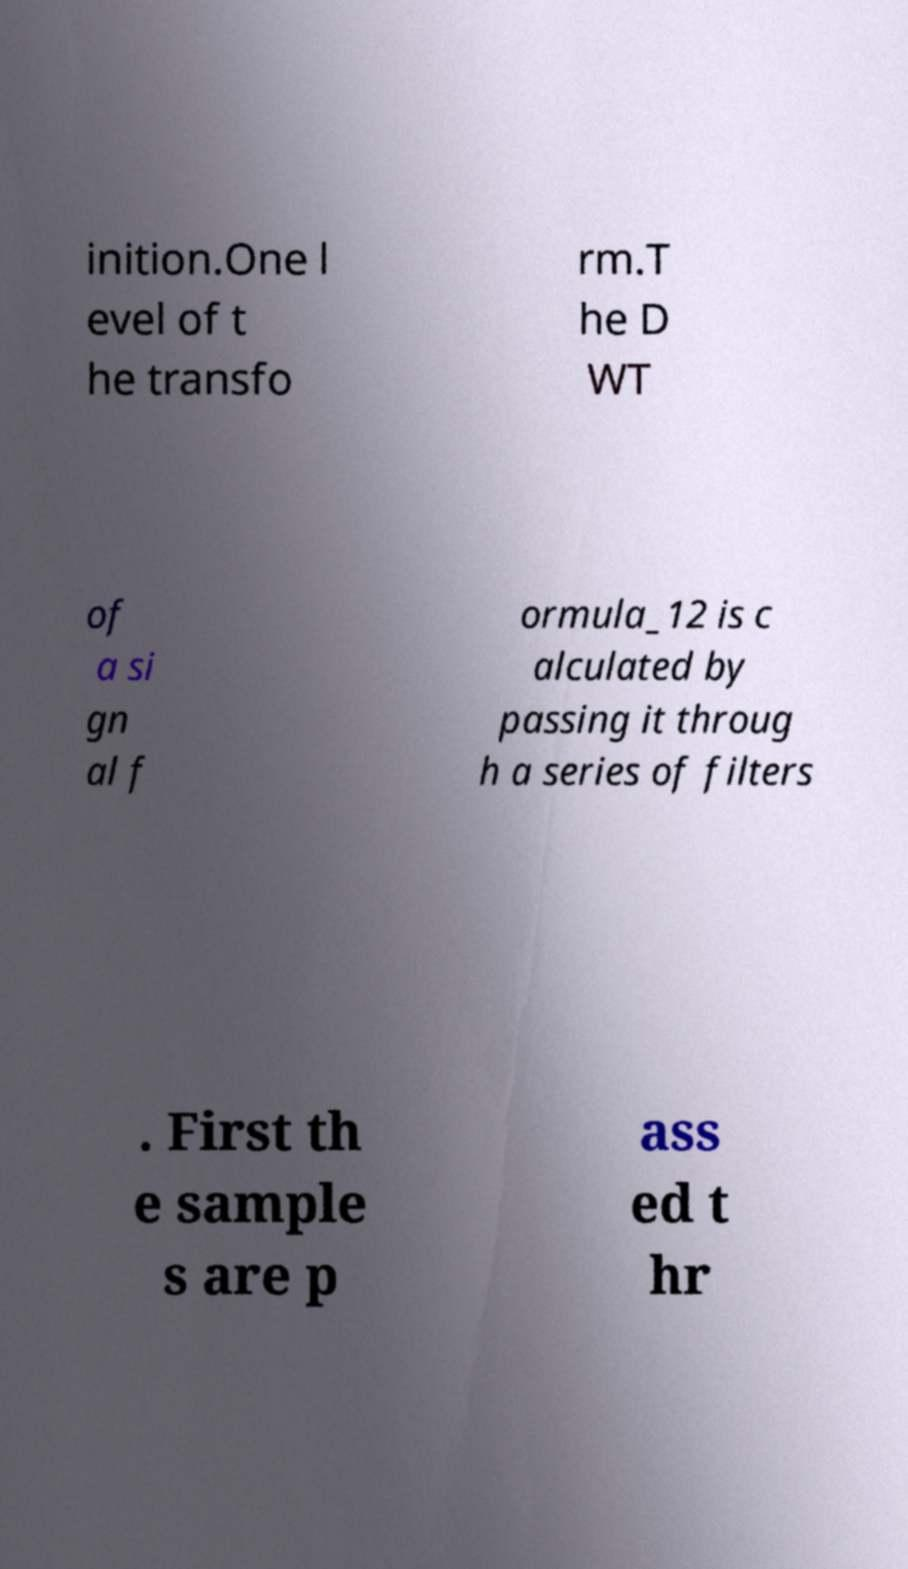There's text embedded in this image that I need extracted. Can you transcribe it verbatim? inition.One l evel of t he transfo rm.T he D WT of a si gn al f ormula_12 is c alculated by passing it throug h a series of filters . First th e sample s are p ass ed t hr 